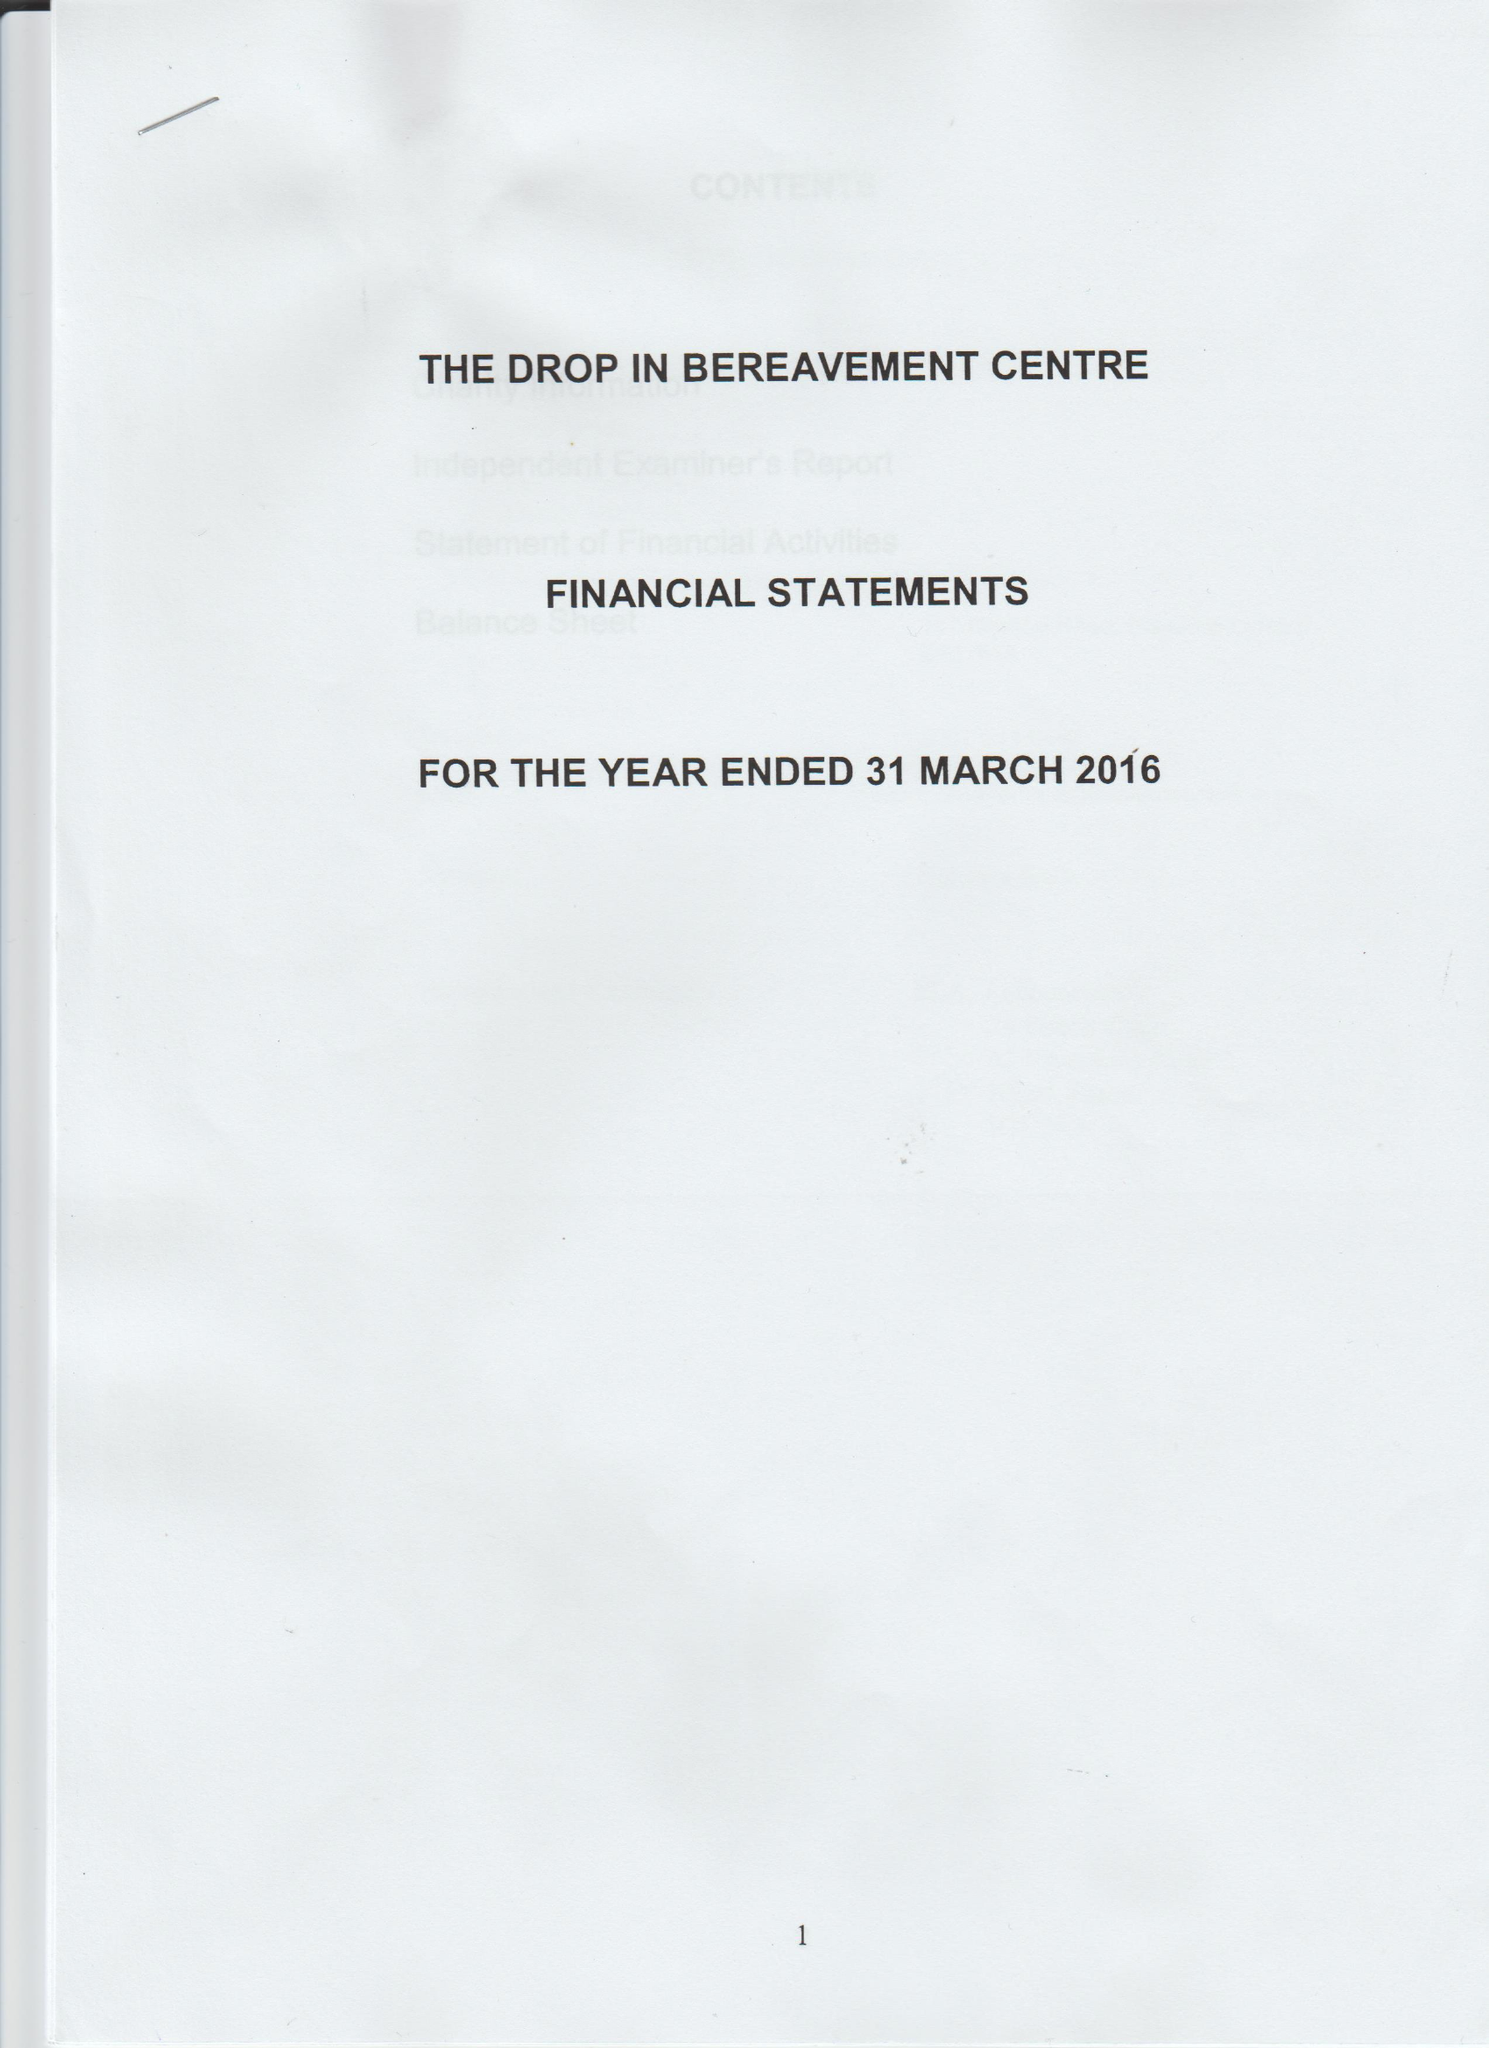What is the value for the charity_number?
Answer the question using a single word or phrase. 1161526 